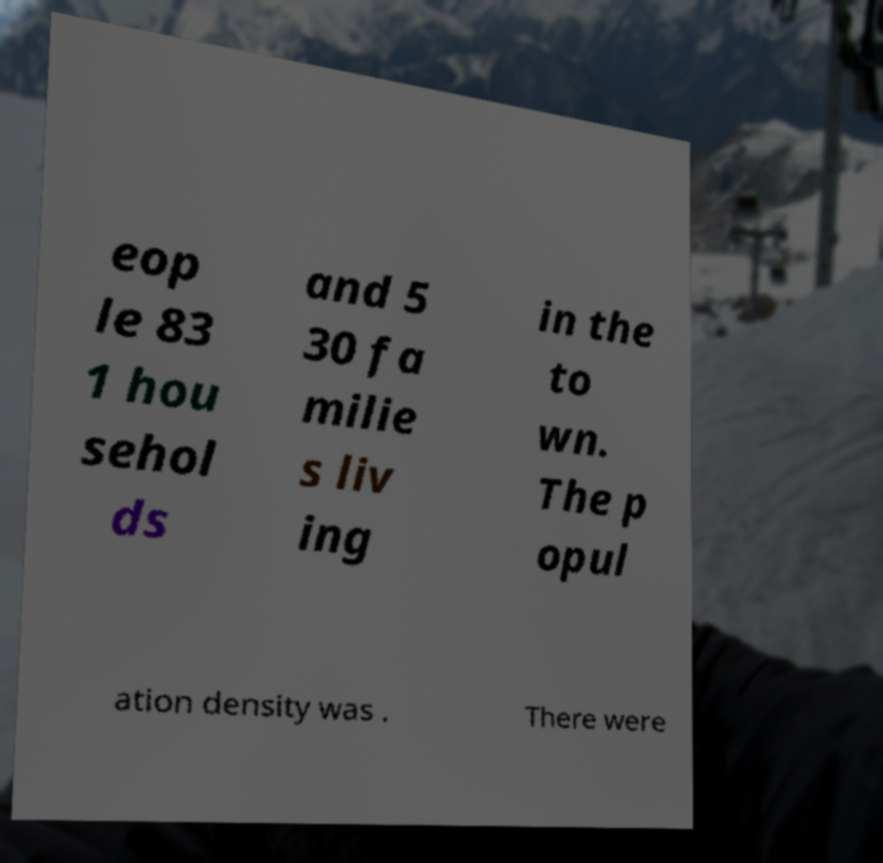There's text embedded in this image that I need extracted. Can you transcribe it verbatim? eop le 83 1 hou sehol ds and 5 30 fa milie s liv ing in the to wn. The p opul ation density was . There were 